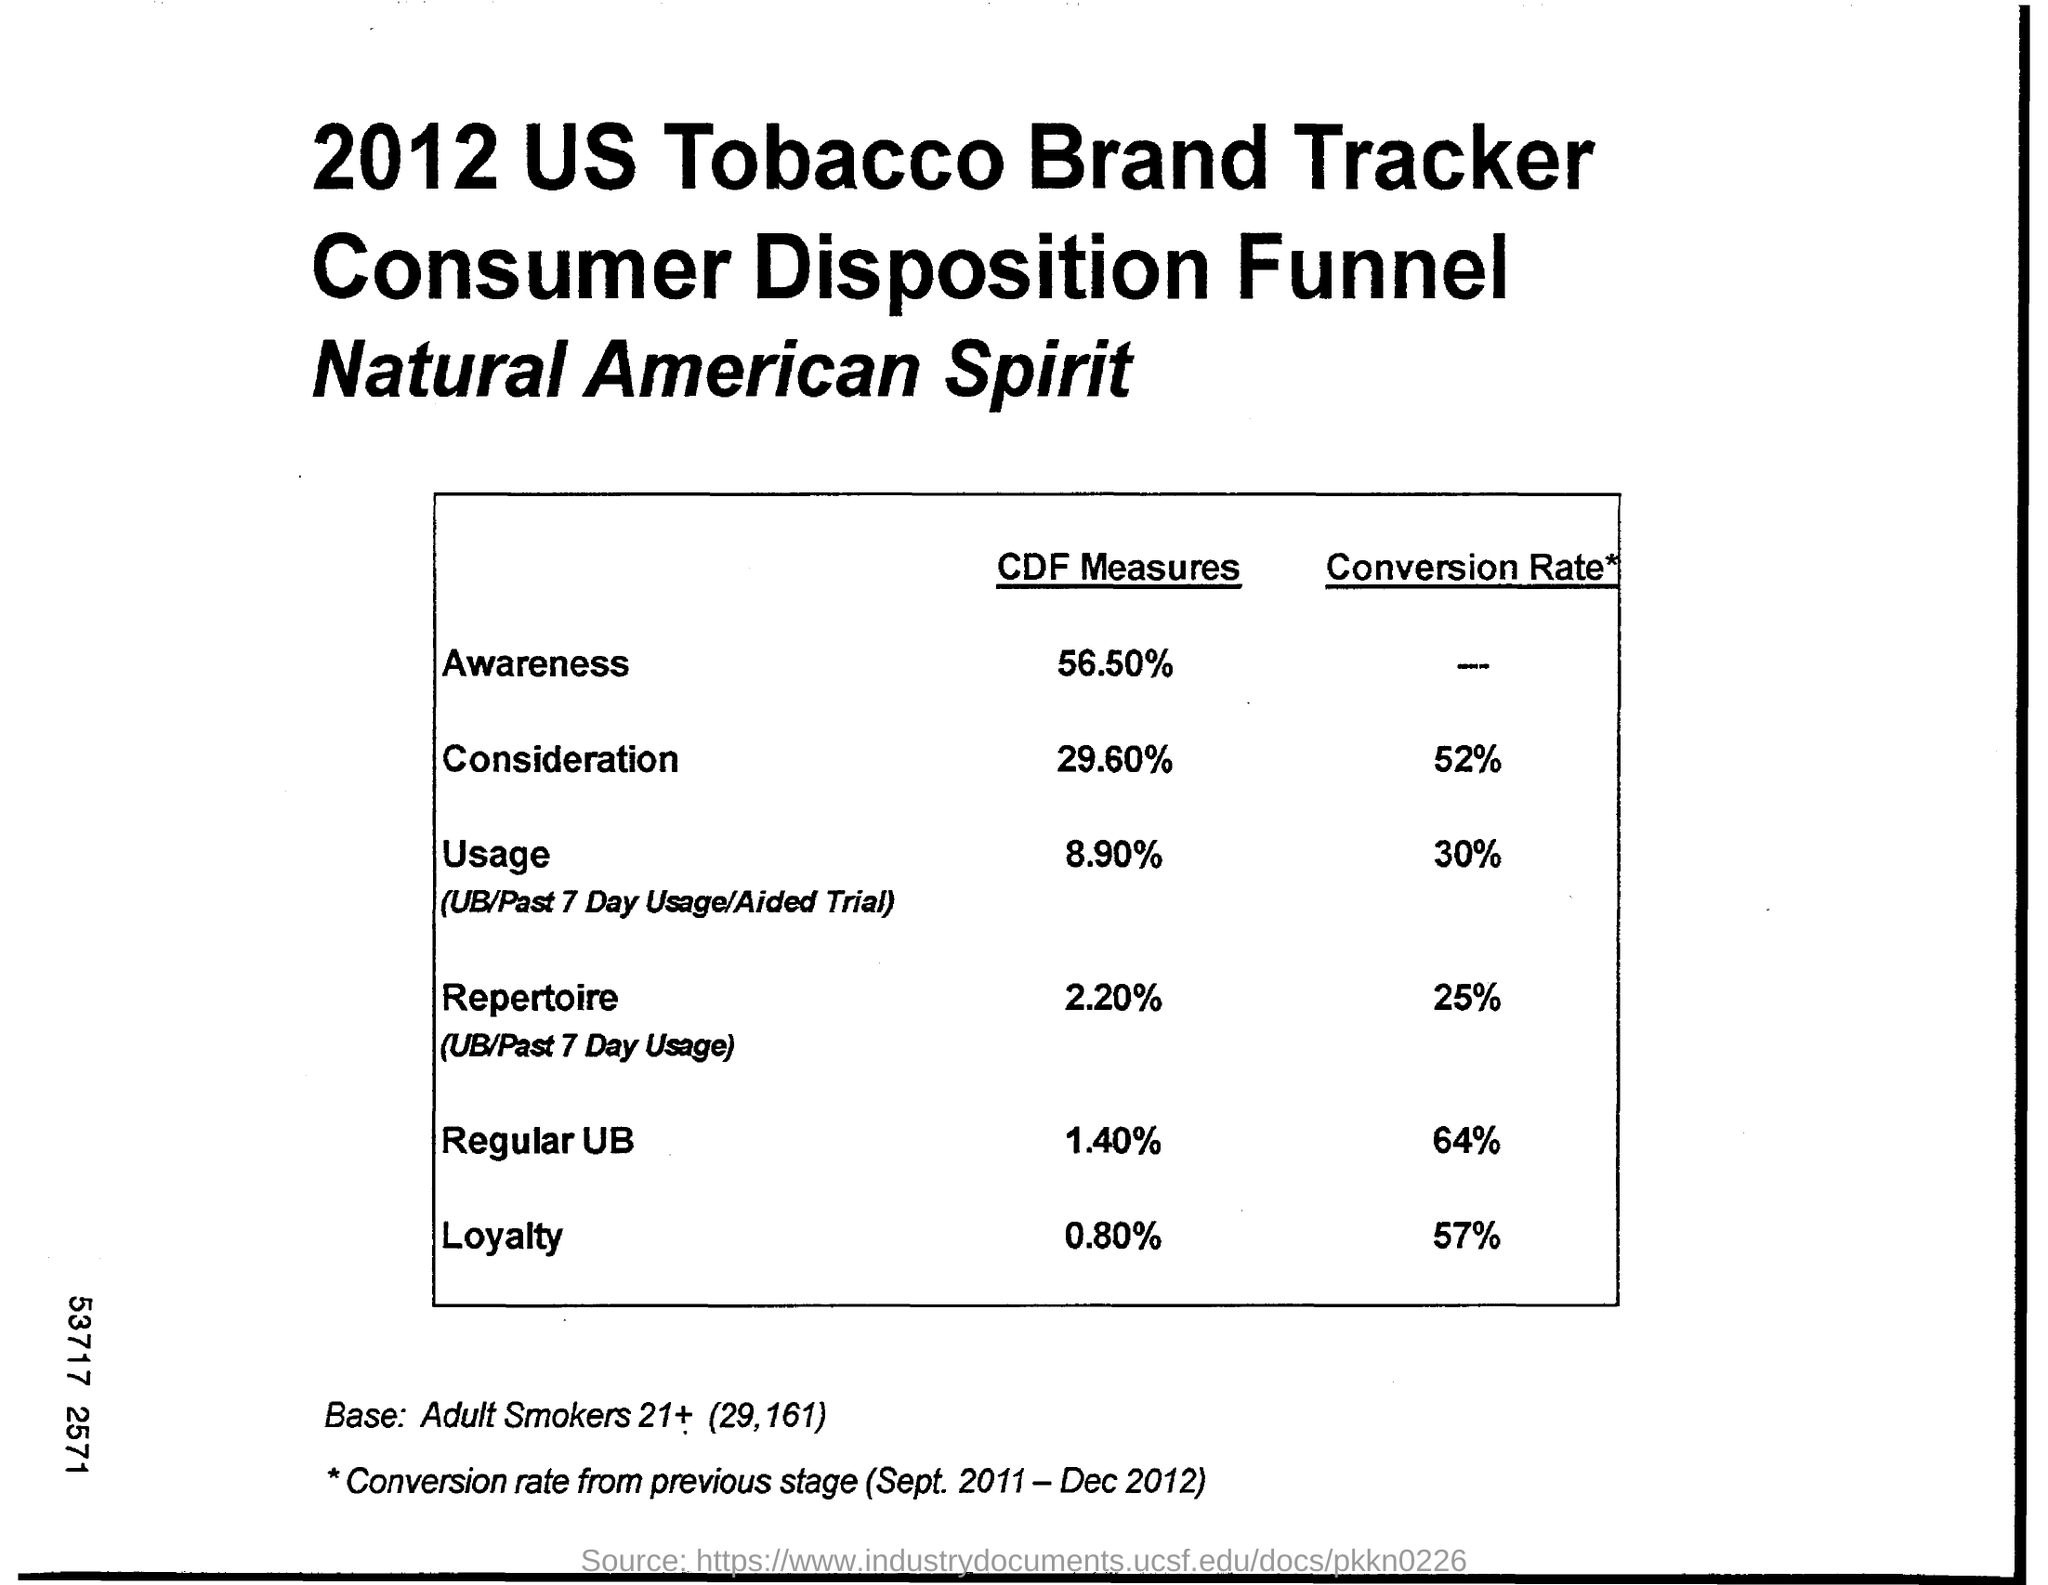What is the Conversion Rate for Consideration?
Make the answer very short. 52%. What is the Conversion Rate for "Regular UB"?
Give a very brief answer. 64%. 